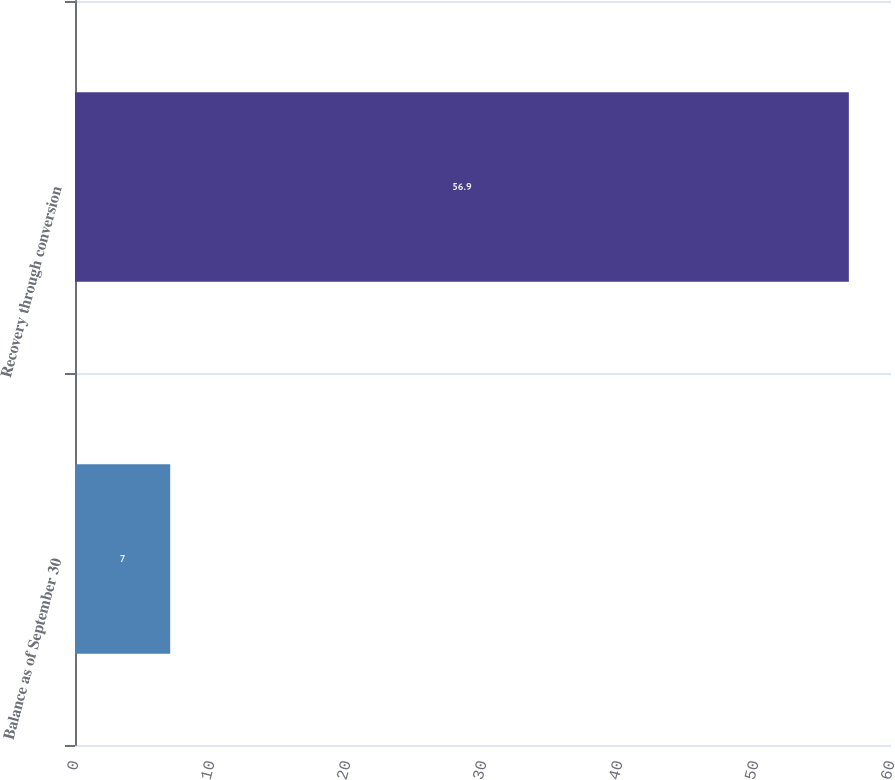Convert chart to OTSL. <chart><loc_0><loc_0><loc_500><loc_500><bar_chart><fcel>Balance as of September 30<fcel>Recovery through conversion<nl><fcel>7<fcel>56.9<nl></chart> 